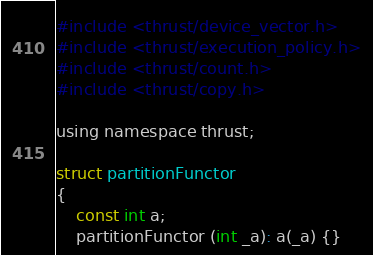Convert code to text. <code><loc_0><loc_0><loc_500><loc_500><_Cuda_>#include <thrust/device_vector.h>
#include <thrust/execution_policy.h>
#include <thrust/count.h>
#include <thrust/copy.h>

using namespace thrust;

struct partitionFunctor
{
	const int a;
	partitionFunctor (int _a): a(_a) {}</code> 